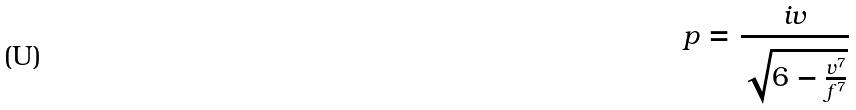<formula> <loc_0><loc_0><loc_500><loc_500>p = \frac { i v } { \sqrt { 6 - \frac { v ^ { 7 } } { f ^ { 7 } } } }</formula> 